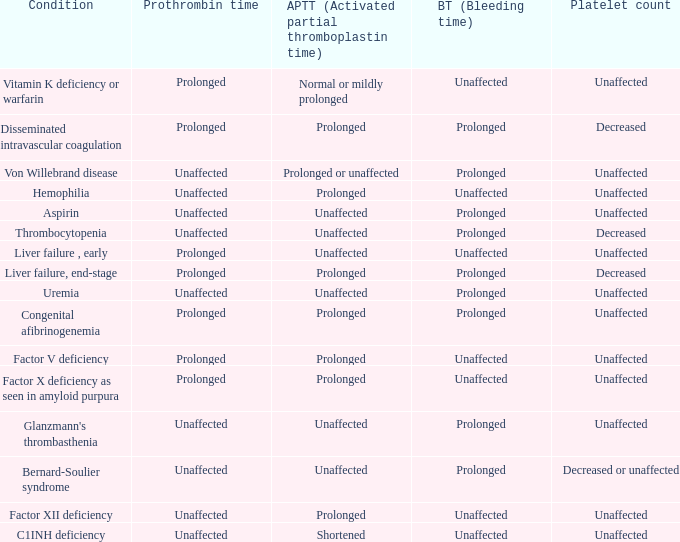Which Platelet count has a Condition of factor v deficiency? Unaffected. 